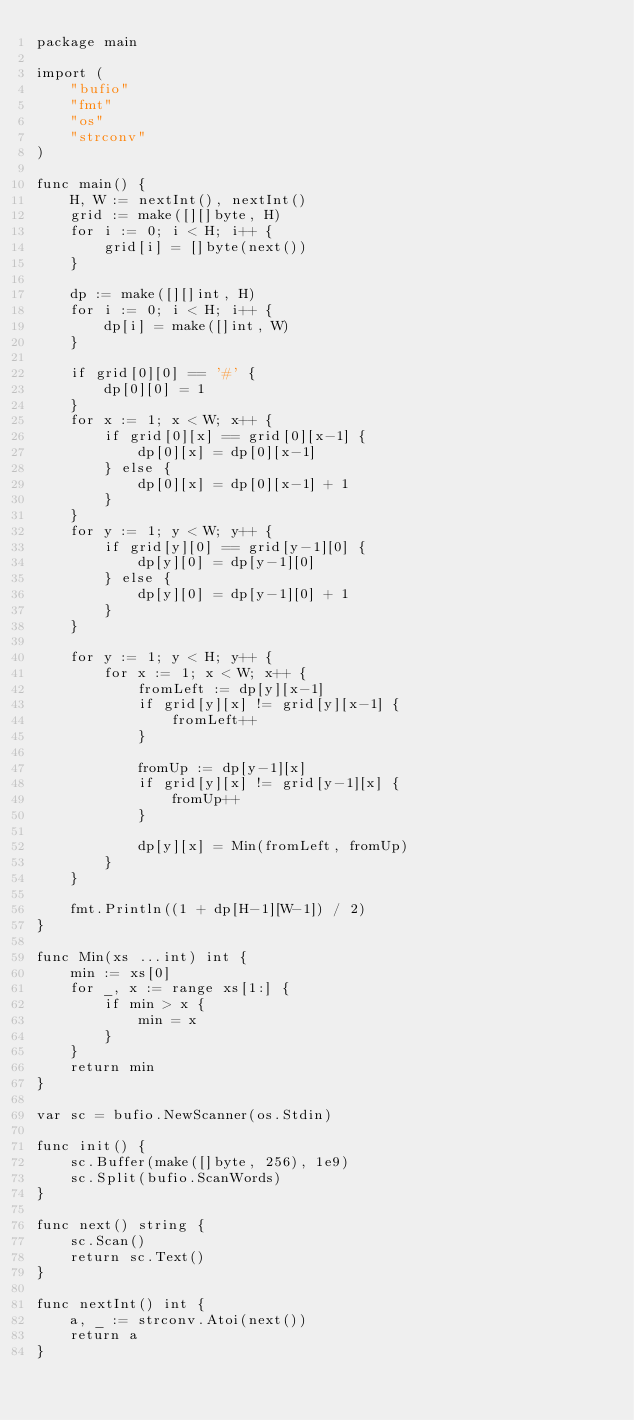Convert code to text. <code><loc_0><loc_0><loc_500><loc_500><_Go_>package main

import (
	"bufio"
	"fmt"
	"os"
	"strconv"
)

func main() {
	H, W := nextInt(), nextInt()
	grid := make([][]byte, H)
	for i := 0; i < H; i++ {
		grid[i] = []byte(next())
	}

	dp := make([][]int, H)
	for i := 0; i < H; i++ {
		dp[i] = make([]int, W)
	}

	if grid[0][0] == '#' {
		dp[0][0] = 1
	}
	for x := 1; x < W; x++ {
		if grid[0][x] == grid[0][x-1] {
			dp[0][x] = dp[0][x-1]
		} else {
			dp[0][x] = dp[0][x-1] + 1
		}
	}
	for y := 1; y < W; y++ {
		if grid[y][0] == grid[y-1][0] {
			dp[y][0] = dp[y-1][0]
		} else {
			dp[y][0] = dp[y-1][0] + 1
		}
	}

	for y := 1; y < H; y++ {
		for x := 1; x < W; x++ {
			fromLeft := dp[y][x-1]
			if grid[y][x] != grid[y][x-1] {
				fromLeft++
			}

			fromUp := dp[y-1][x]
			if grid[y][x] != grid[y-1][x] {
				fromUp++
			}

			dp[y][x] = Min(fromLeft, fromUp)
		}
	}

	fmt.Println((1 + dp[H-1][W-1]) / 2)
}

func Min(xs ...int) int {
	min := xs[0]
	for _, x := range xs[1:] {
		if min > x {
			min = x
		}
	}
	return min
}

var sc = bufio.NewScanner(os.Stdin)

func init() {
	sc.Buffer(make([]byte, 256), 1e9)
	sc.Split(bufio.ScanWords)
}

func next() string {
	sc.Scan()
	return sc.Text()
}

func nextInt() int {
	a, _ := strconv.Atoi(next())
	return a
}
</code> 